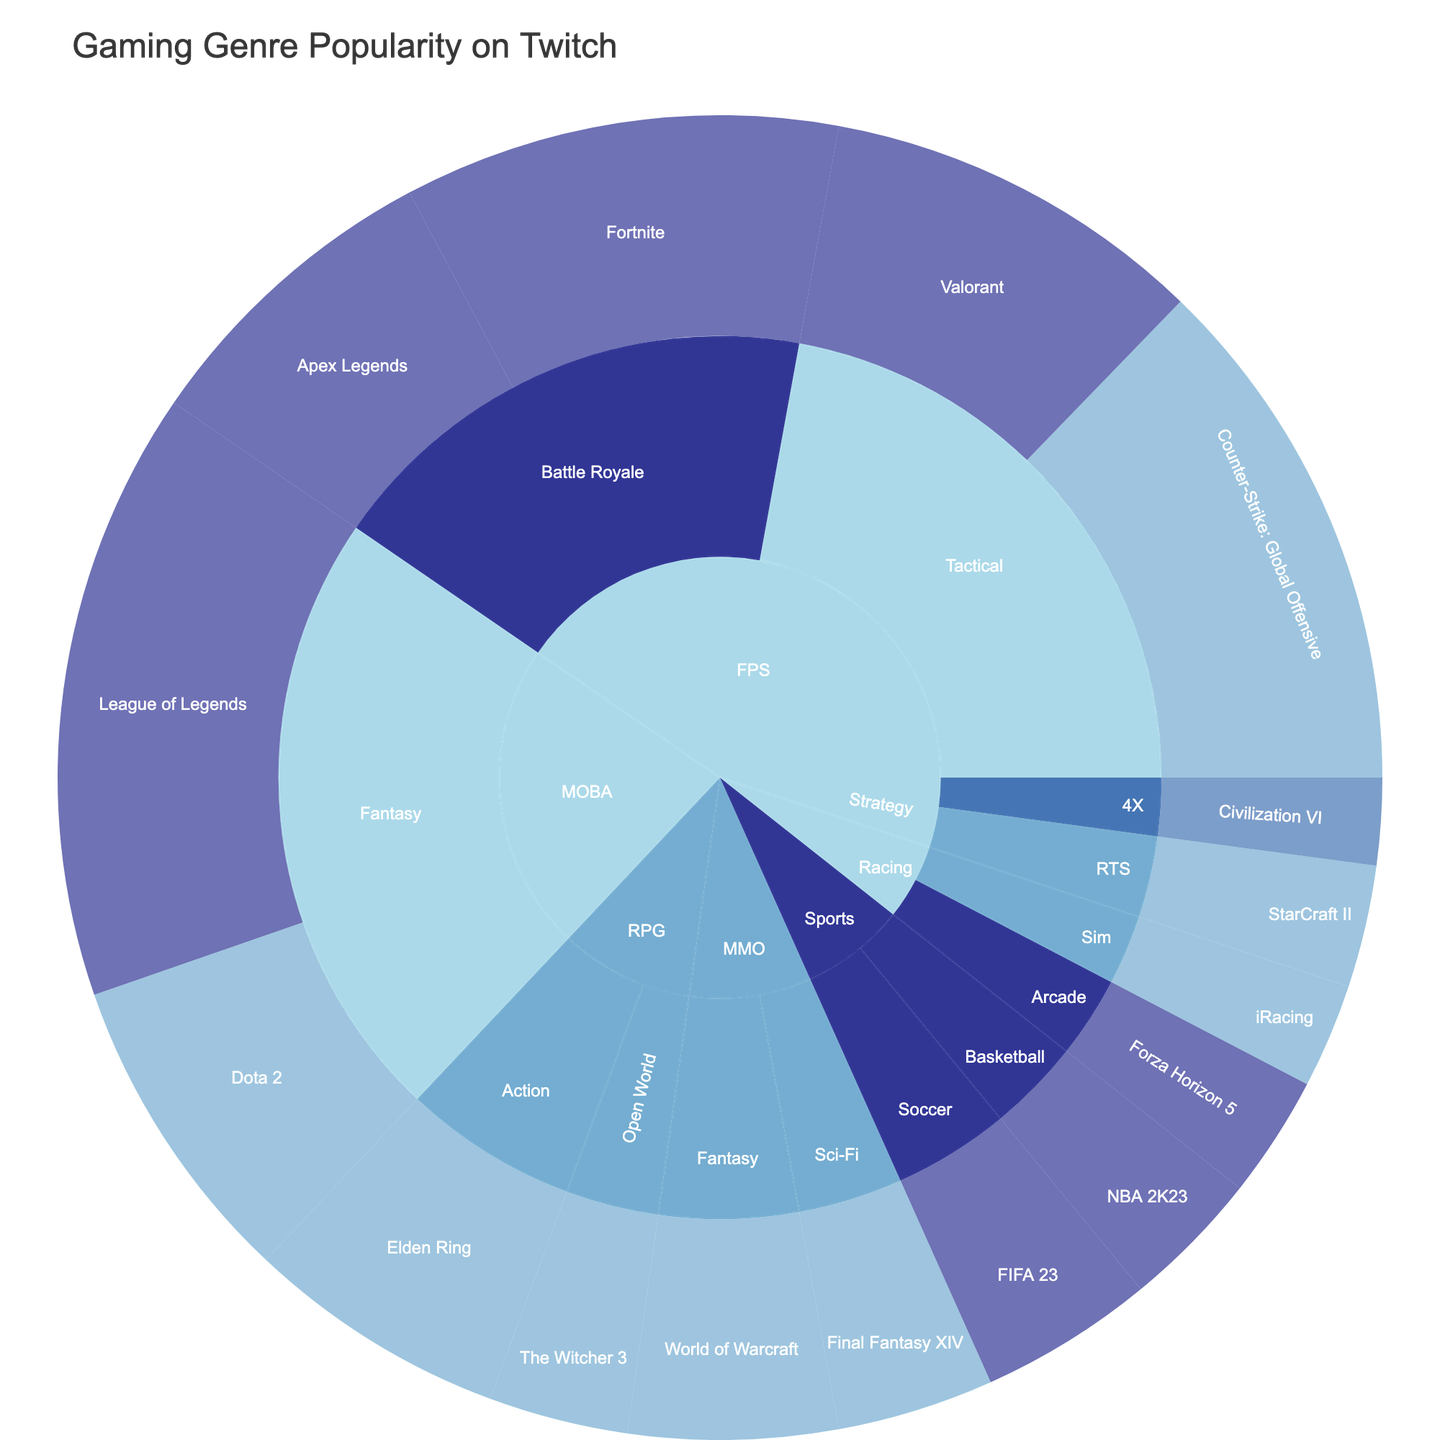What genre has the highest total number of viewers on Twitch? To determine the genre with the highest total number of viewers, sum up the viewers for each genre and compare the totals. FPS: 250000 (Fortnite) + 180000 (Apex Legends) + 300000 (Counter-Strike) + 220000 (Valorant) = 950000; MOBA: 350000 (League of Legends) + 180000 (Dota 2) = 530000; MMO: 120000 (World of Warcraft) + 90000 (Final Fantasy XIV) = 210000; RPG: 150000 (Elden Ring) + 80000 (The Witcher 3) = 230000; Strategy: 70000 (StarCraft II) + 50000 (Civilization VI) = 120000; Sports: 100000 (FIFA 23) + 80000 (NBA 2K23) = 180000; Racing: 60000 (iRacing) + 70000 (Forza Horizon 5) = 130000. The FPS genre has the highest total number of viewers.
Answer: FPS Which specific game attracts the most viewers on Twitch? Look at the number of viewers for each game displayed in the plot. The game with the highest number of viewers will be the answer. From the provided data, the game "League of Legends" under the MOBA genre and Fantasy category has the highest number of viewers at 350000.
Answer: League of Legends What is the color representing the 18-24 age group? Refer to the legend in the figure to identify the color associated with the 18-24 age group. The color scale used in the figure will display colors corresponding to different age groups.
Answer: Refer to Legend Which game has more viewers: Fortnite or Valorant? Compare the number of viewers for "Fortnite" and "Valorant" by looking at their respective sections in the plot. Fortnite has 250000 viewers and Valorant has 220000 viewers. Therefore, Fortnite has more viewers than Valorant.
Answer: Fortnite What is the total number of viewers for the Tactical category under FPS? Sum the viewers of all games under the Tactical category within the FPS genre. Counter-Strike: Global Offensive has 300000 viewers and Valorant has 220000 viewers. Total: 300000 + 220000 = 520000.
Answer: 520000 Which age group is more interested in MOBA games, and what games are they watching? Look at the MOBA genre section and identify the age groups associated with that genre's games. League of Legends, with 350000 viewers, falls under the 18-24 age group. Dota 2, with 180000 viewers, is under the 25-34 age group. The 18-24 age group appears to be more interested, and they are watching League of Legends.
Answer: 18-24, League of Legends How do the viewer counts of the Racing genre compare to the Strategy genre? Calculate the total viewers for each genre by summing their respective viewer counts. Racing: 60000 (iRacing) + 70000 (Forza Horizon 5) = 130000; Strategy: 70000 (StarCraft II) + 50000 (Civilization VI) = 120000. Racing has slightly more viewers than Strategy by 10000 viewers.
Answer: Racing What game under the RPG genre has the highest number of viewers, and what is the age group associated with it? Look at the RPG genre section and identify the game with the highest number of viewers. Elden Ring has 150000 viewers, and it is associated with the 25-34 age group.
Answer: Elden Ring, 25-34 Compare the popularity of Soccer and Basketball within the Sports genre on Twitch. Which one is more popular and by how many viewers? Sum the viewer counts of games under the Soccer and Basketball categories. Soccer (FIFA 23) has 100000 viewers and Basketball (NBA 2K23) has 80000 viewers. Compare the viewer counts: Soccer is more popular by 20000 viewers.
Answer: Soccer, 20000 